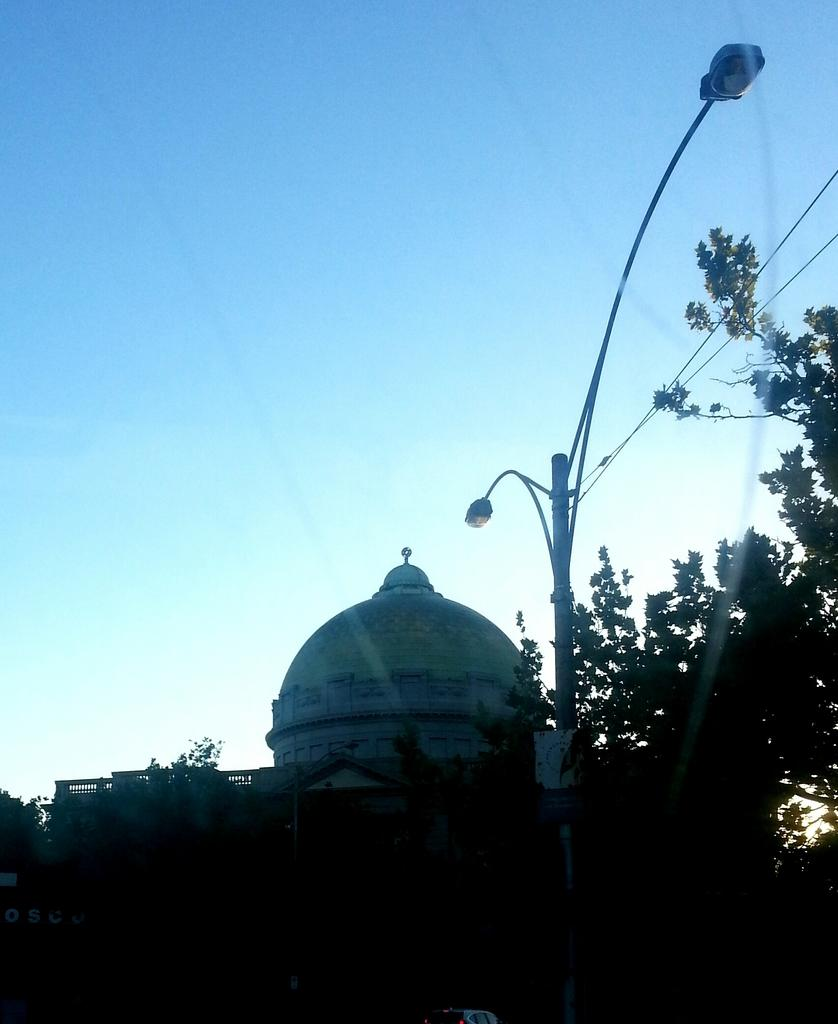What is the main object in the center of the image? There is a light pole in the center of the image. What can be seen in the background of the image? There is a building and the sky visible in the background of the image. Are there any natural elements in the image? Yes, there are trees in the image. What type of insurance policy is being discussed in the image? There is no discussion of insurance policies in the image; it features a light pole, a building, the sky, and trees. 